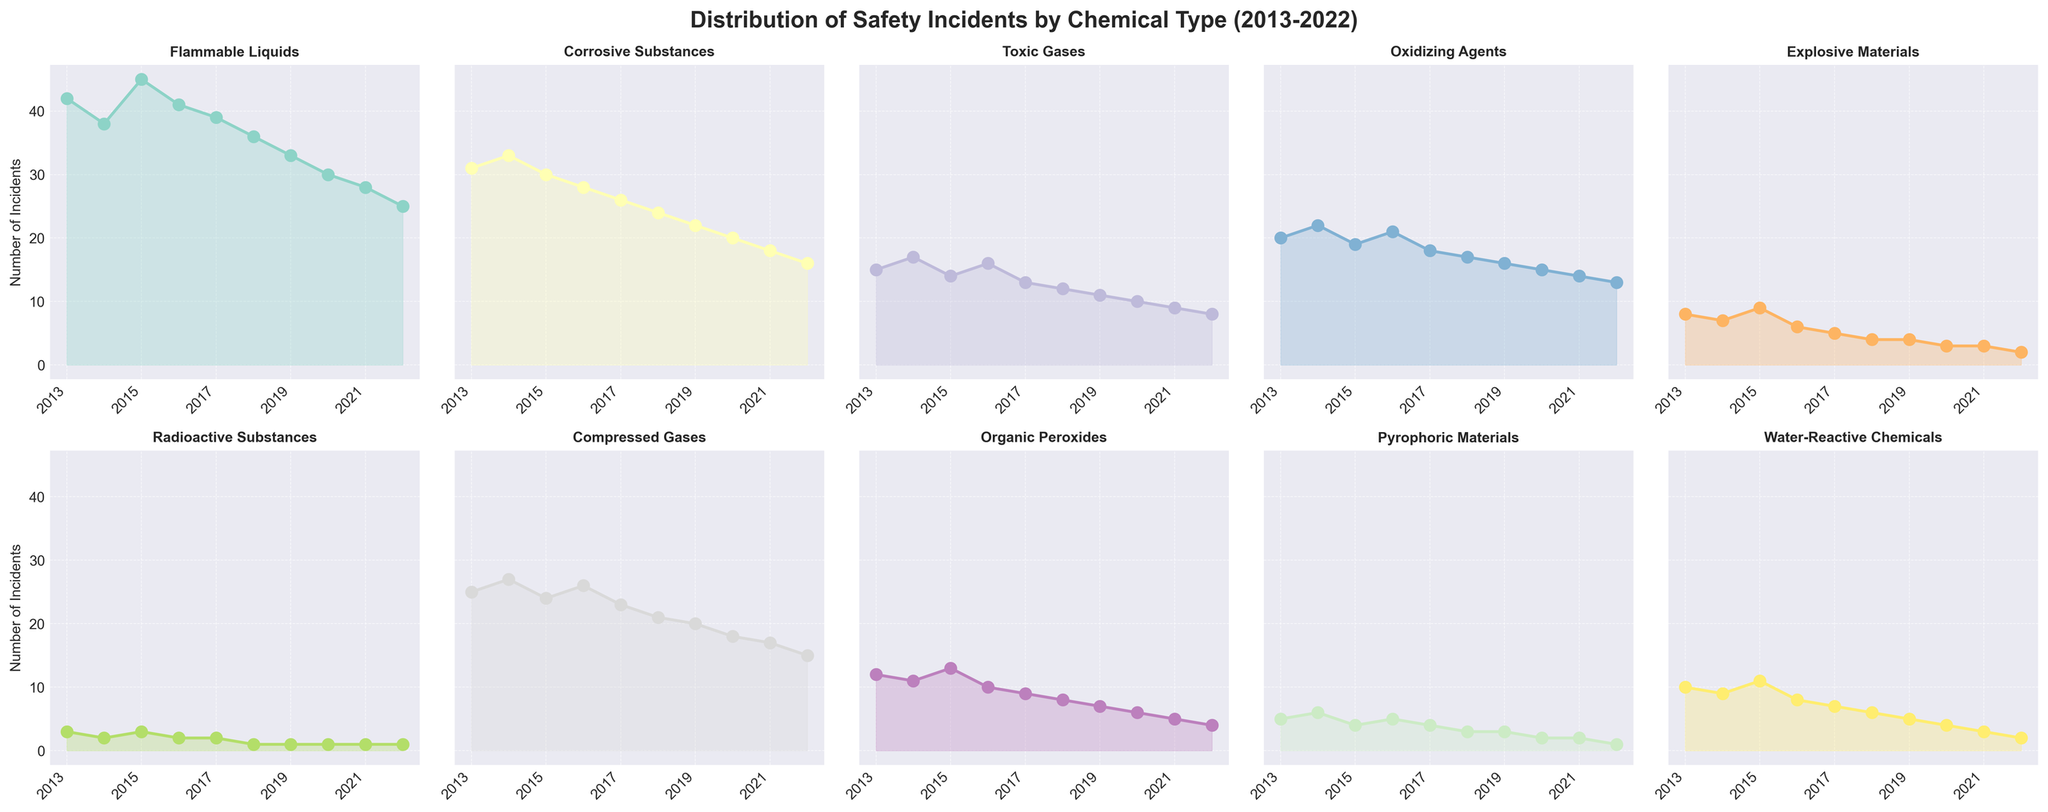What's the total number of safety incidents for Flammable Liquids from 2013 to 2022? Sum the incidents from each year for Flammable Liquids: 42 + 38 + 45 + 41 + 39 + 36 + 33 + 30 + 28 + 25 = 357
Answer: 357 Which chemical type saw the largest decrease in the number of incidents from 2013 to 2022? Compare the number of incidents in 2013 with those in 2022 for each chemical type. Flammable Liquids decreased from 42 to 25, Corrosive Substances from 31 to 16, Toxic Gases from 15 to 8, Oxidizing Agents from 20 to 13, Explosive Materials from 8 to 2, Radioactive Substances from 3 to 1, Compressed Gases from 25 to 15, Organic Peroxides from 12 to 4, Pyrophoric Materials from 5 to 1, Water-Reactive Chemicals from 10 to 2. Thus, Flammable Liquids decreased by 17 and Corrosive Substances by 15, and so on. Explosive Materials saw the largest decrease (6).
Answer: Explosive Materials In which year did the number of incidents for Toxic Gases peak? Look at the line for Toxic Gases and identify the year with the highest point. Toxic Gases peaked in 2016 with 16 incidents.
Answer: 2016 Between 2016 and 2020, which chemical type shows the most consistent decline in the number of incidents? We need to observe declining patterns between 2016 and 2020. Flammable Liquids reduce consistently from 41 to 30. Corrosive Substances decline from 28 to 20. Toxic Gases drop from 16 to 10. Oxidizing Agents go from 21 to 15. Explosive Materials are stable from 6 to 3 across the years. Radioactive Substances remain stable, Compressed Gases drop from 26 to 18. Organic Peroxides decline from 10 to 6. Pyrophoric Materials drop from 5 to 2 and Water-Reactive Chemicals reduce from 8 to 4. Flammable Liquids is the most consistent.
Answer: Flammable Liquids How many chemical types had 10 or fewer incidents in 2022? Look at each chemical type's incidents for 2022 to count those with 10 or fewer incidents. Flammable Liquids (25), Corrosive Substances (16), Toxic Gases (8), Oxidizing Agents (13), Explosive Materials (2), Radioactive Substances (1), Compressed Gases (15), Organic Peroxides (4), Pyrophoric Materials (1), Water-Reactive Chemicals (2). Five chemical types (Toxic Gases, Explosive Materials, Radioactive Substances, Organic Peroxides, Pyrophoric Materials, and Water-Reactive Chemicals).
Answer: 6 Which chemical types had the same number of incidents in 2017? Compare the number of incidents for each chemical type in 2017. Flammable Liquids (39), Corrosive Substances (26), Toxic Gases (13), Oxidizing Agents (18), Explosive Materials (5), Radioactive Substances (2), Compressed Gases (23), Organic Peroxides (9), Pyrophoric Materials (4), Water-Reactive Chemicals (7). None of the chemical types had the same number of incidents in 2017.
Answer: None What is the average number of incidents per year for Compressed Gases? Sum the annual incidents for Compressed Gases and divide by the number of years (10): (25 + 27 + 24 + 26 + 23 + 21 + 20 + 18 + 17 + 15) / 10 = 216 / 10 = 21.6
Answer: 21.6 Did any chemical type have a year where incidents remained the same as the previous year? Check the incidents for each chemical type year by year. Radioactive Substances remained at 2 from 2013-2014 and 1 from 2017-2022.
Answer: Yes, Radioactive Substances Which chemical type had the least number of incidents overall from 2013 to 2022? Sum the incidents of each chemical type over the period. Radioactive Substances had totals of 3 + 2 + 3 + 2 + 2 + 1 + 1 + 1 + 1 + 1 = 17, which is the least.
Answer: Radioactive Substances 